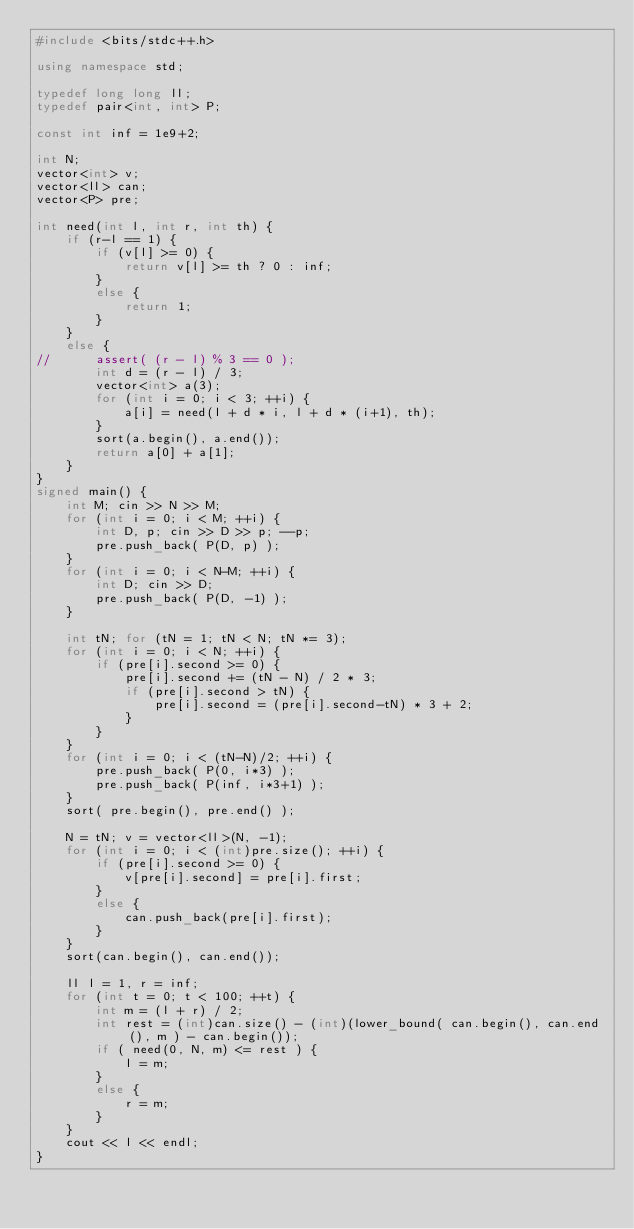Convert code to text. <code><loc_0><loc_0><loc_500><loc_500><_C++_>#include <bits/stdc++.h>

using namespace std;

typedef long long ll;
typedef pair<int, int> P;

const int inf = 1e9+2;

int N;
vector<int> v;
vector<ll> can;
vector<P> pre;

int need(int l, int r, int th) {
	if (r-l == 1) {
		if (v[l] >= 0) {
			return v[l] >= th ? 0 : inf;
		}
		else {
			return 1;
		}
	}
	else {
//		assert( (r - l) % 3 == 0 );
		int d = (r - l) / 3;
		vector<int> a(3);
		for (int i = 0; i < 3; ++i) {
			a[i] = need(l + d * i, l + d * (i+1), th);
		}
		sort(a.begin(), a.end());
		return a[0] + a[1];
	}
}
signed main() {
	int M; cin >> N >> M;
	for (int i = 0; i < M; ++i) {
		int D, p; cin >> D >> p; --p;
		pre.push_back( P(D, p) );
	}
	for (int i = 0; i < N-M; ++i) {
		int D; cin >> D;
		pre.push_back( P(D, -1) );
	}

	int tN; for (tN = 1; tN < N; tN *= 3);
	for (int i = 0; i < N; ++i) {
		if (pre[i].second >= 0) {
			pre[i].second += (tN - N) / 2 * 3;
			if (pre[i].second > tN) {
				pre[i].second = (pre[i].second-tN) * 3 + 2;
			}
		}
	}
	for (int i = 0; i < (tN-N)/2; ++i) {
		pre.push_back( P(0, i*3) );
		pre.push_back( P(inf, i*3+1) );
	}
	sort( pre.begin(), pre.end() );

	N = tN; v = vector<ll>(N, -1);
	for (int i = 0; i < (int)pre.size(); ++i) {
		if (pre[i].second >= 0) {
			v[pre[i].second] = pre[i].first;
		}
		else {
			can.push_back(pre[i].first);
		}
	}
	sort(can.begin(), can.end());

	ll l = 1, r = inf;
	for (int t = 0; t < 100; ++t) {
		int m = (l + r) / 2;
		int rest = (int)can.size() - (int)(lower_bound( can.begin(), can.end(), m ) - can.begin());
		if ( need(0, N, m) <= rest ) {
			l = m;
		}
		else {
			r = m;
		}
	}
	cout << l << endl;
}</code> 